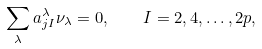<formula> <loc_0><loc_0><loc_500><loc_500>\sum _ { \lambda } a ^ { \lambda } _ { j I } \nu _ { \lambda } = 0 , \quad I = 2 , 4 , \dots , 2 p ,</formula> 